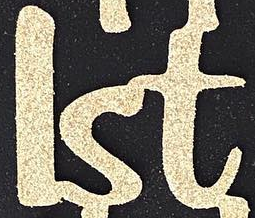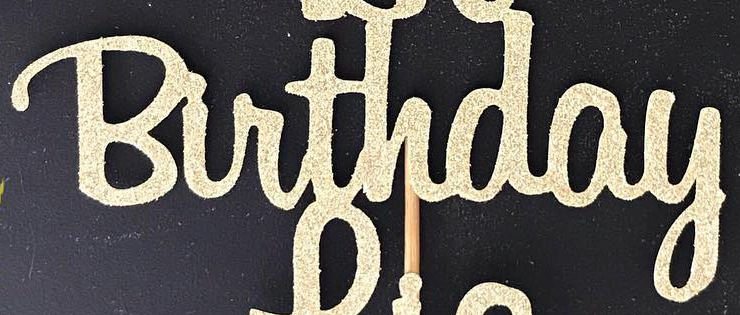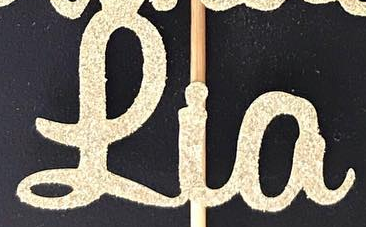What words can you see in these images in sequence, separated by a semicolon? lst; Birthday; Lia 